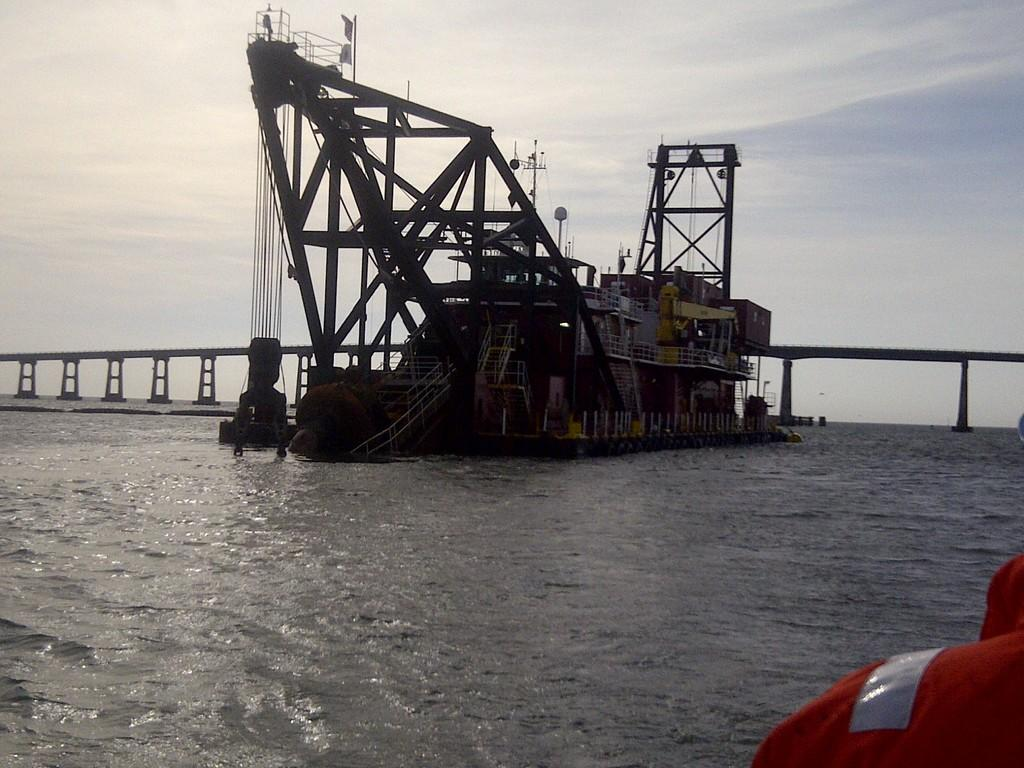What is the main subject of the image? The main subject of the image is a ship on a water surface. What is the ship situated on? The ship is situated on a water surface. What can be seen in the background of the image? There is a bridge visible behind the ship. What type of cord is being used to pull the ship in the image? There is no cord present in the image, and the ship is not being pulled. 